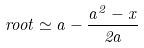Convert formula to latex. <formula><loc_0><loc_0><loc_500><loc_500>r o o t \simeq a - \frac { a ^ { 2 } - x } { 2 a }</formula> 